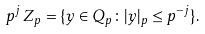Convert formula to latex. <formula><loc_0><loc_0><loc_500><loc_500>p ^ { j } \, { Z } _ { p } = \{ y \in { Q } _ { p } \colon | y | _ { p } \leq p ^ { - j } \} .</formula> 